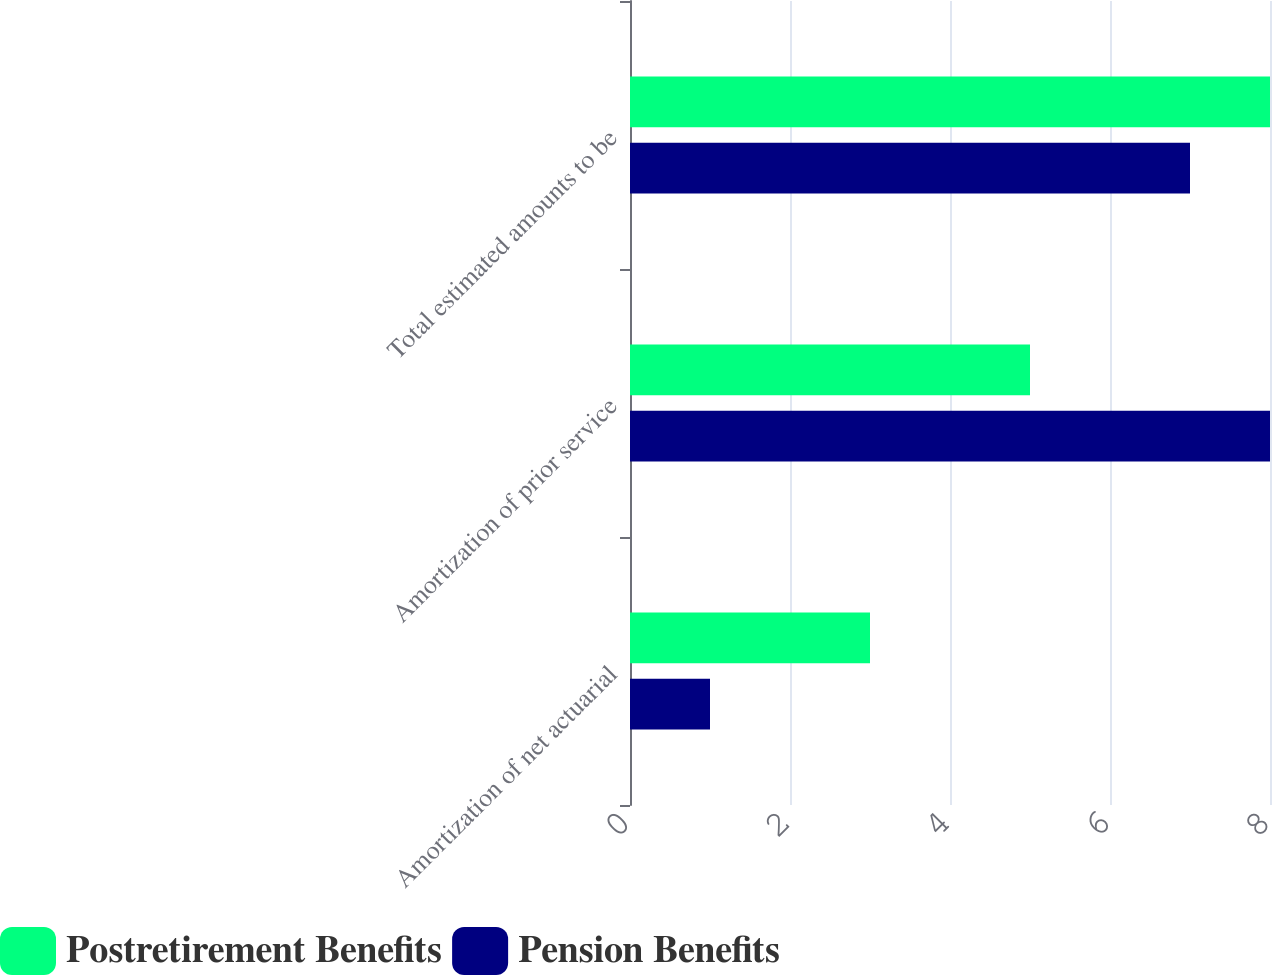<chart> <loc_0><loc_0><loc_500><loc_500><stacked_bar_chart><ecel><fcel>Amortization of net actuarial<fcel>Amortization of prior service<fcel>Total estimated amounts to be<nl><fcel>Postretirement Benefits<fcel>3<fcel>5<fcel>8<nl><fcel>Pension Benefits<fcel>1<fcel>8<fcel>7<nl></chart> 